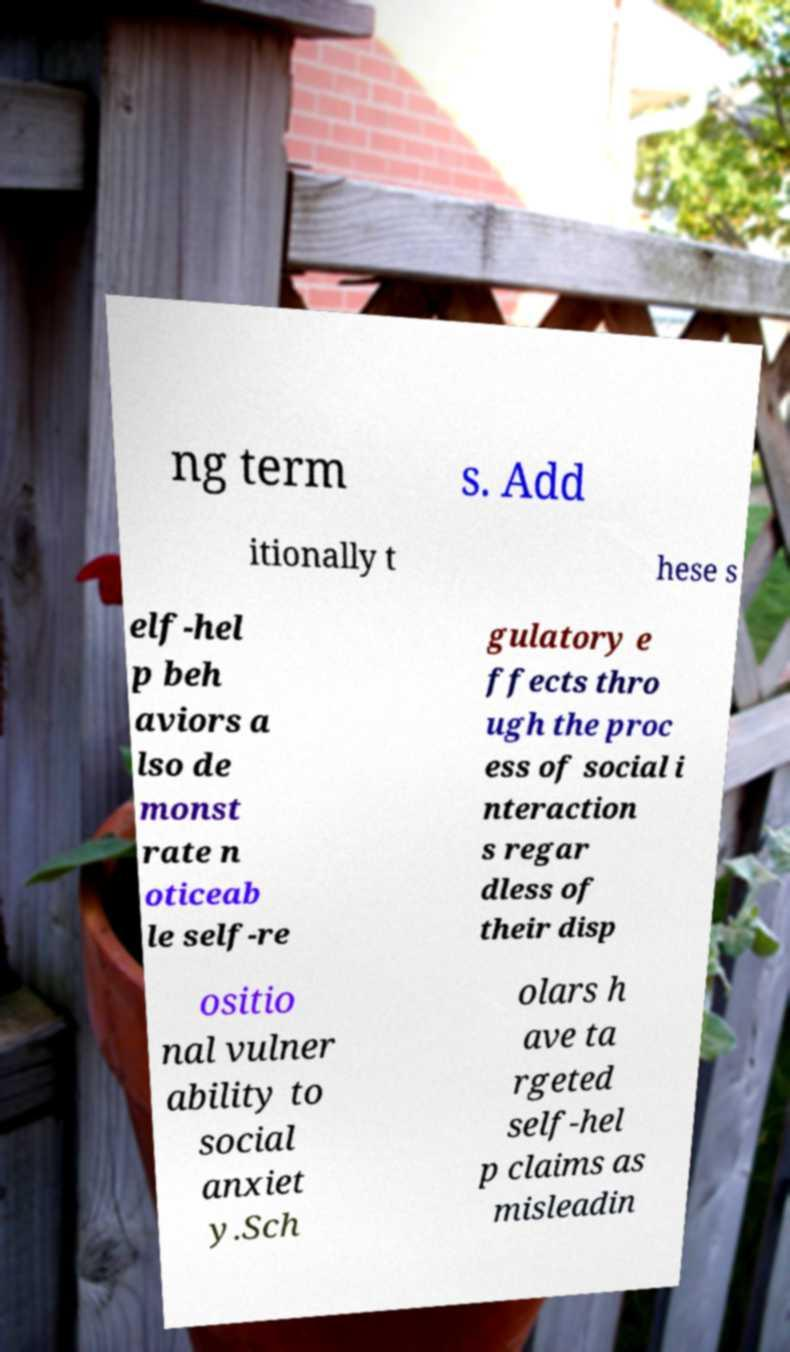There's text embedded in this image that I need extracted. Can you transcribe it verbatim? ng term s. Add itionally t hese s elf-hel p beh aviors a lso de monst rate n oticeab le self-re gulatory e ffects thro ugh the proc ess of social i nteraction s regar dless of their disp ositio nal vulner ability to social anxiet y.Sch olars h ave ta rgeted self-hel p claims as misleadin 